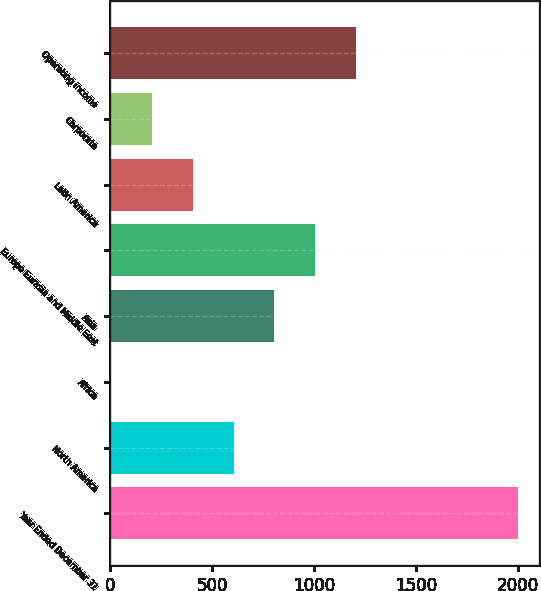Convert chart to OTSL. <chart><loc_0><loc_0><loc_500><loc_500><bar_chart><fcel>Year Ended December 31<fcel>North America<fcel>Africa<fcel>Asia<fcel>Europe Eurasia and Middle East<fcel>Latin America<fcel>Corporate<fcel>Operating income<nl><fcel>2003<fcel>604.26<fcel>4.8<fcel>804.08<fcel>1003.9<fcel>404.44<fcel>204.62<fcel>1203.72<nl></chart> 